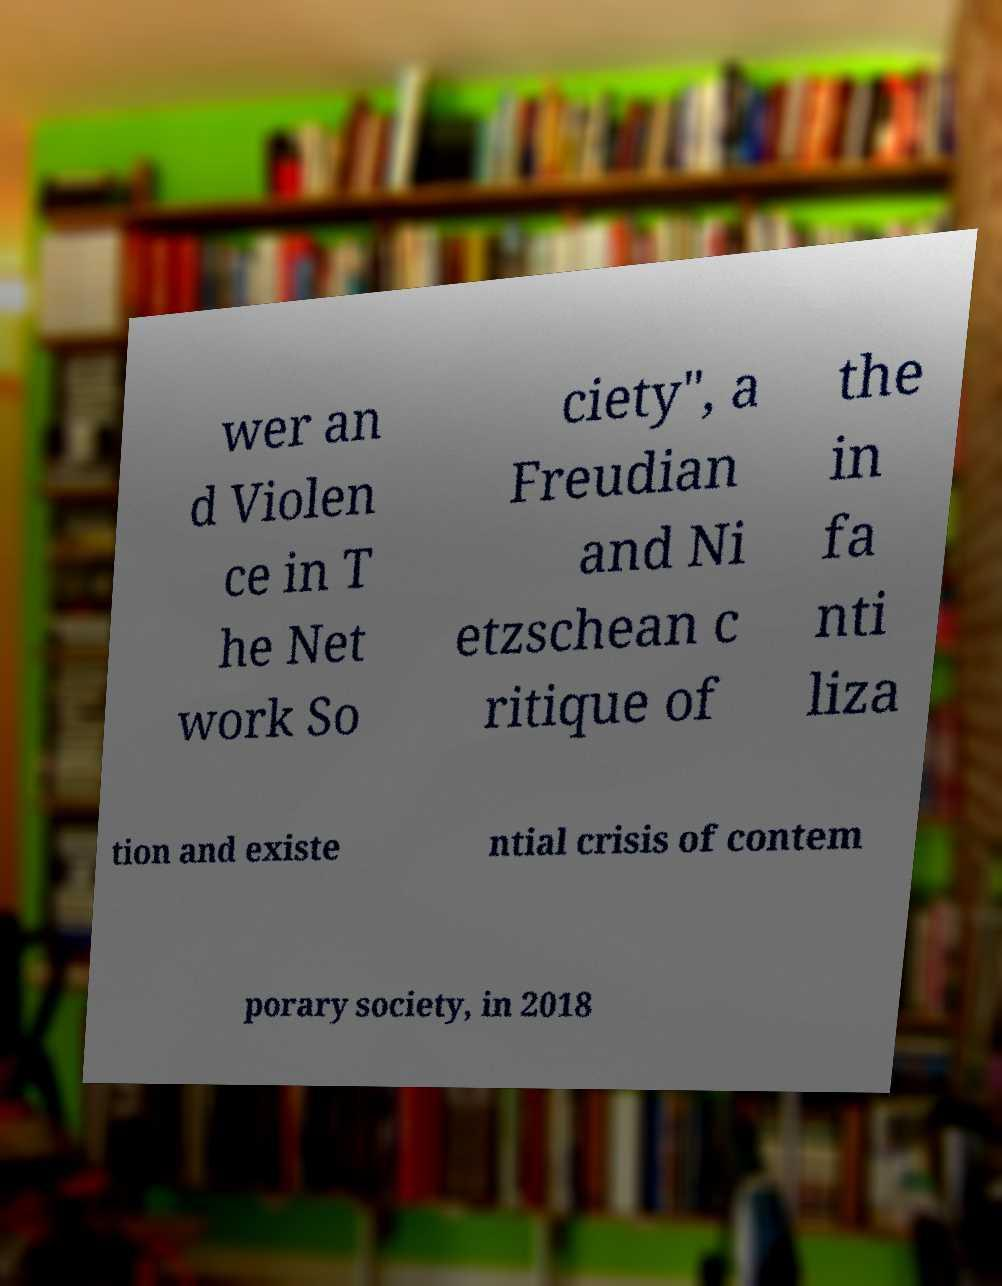Could you extract and type out the text from this image? wer an d Violen ce in T he Net work So ciety", a Freudian and Ni etzschean c ritique of the in fa nti liza tion and existe ntial crisis of contem porary society, in 2018 